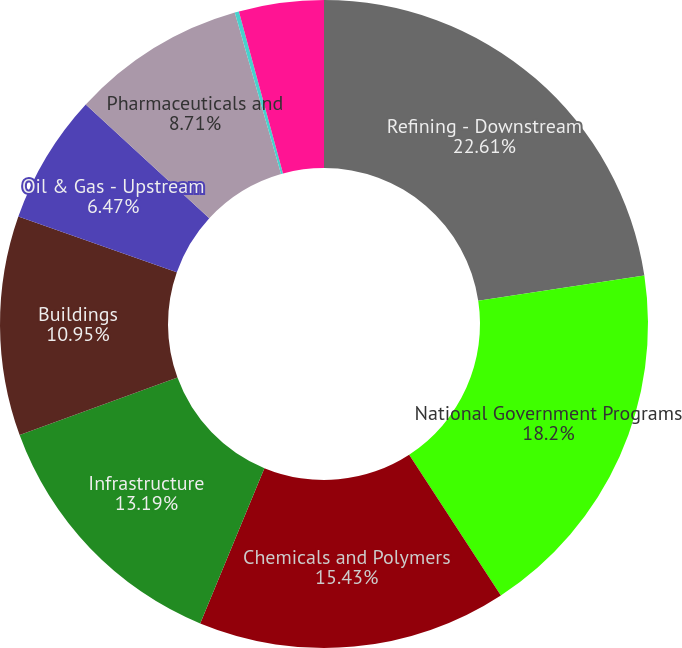Convert chart to OTSL. <chart><loc_0><loc_0><loc_500><loc_500><pie_chart><fcel>Refining - Downstream<fcel>National Government Programs<fcel>Chemicals and Polymers<fcel>Infrastructure<fcel>Buildings<fcel>Oil & Gas - Upstream<fcel>Pharmaceuticals and<fcel>Mining & Minerals<fcel>Industrial and Other<nl><fcel>22.61%<fcel>18.2%<fcel>15.43%<fcel>13.19%<fcel>10.95%<fcel>6.47%<fcel>8.71%<fcel>0.21%<fcel>4.23%<nl></chart> 